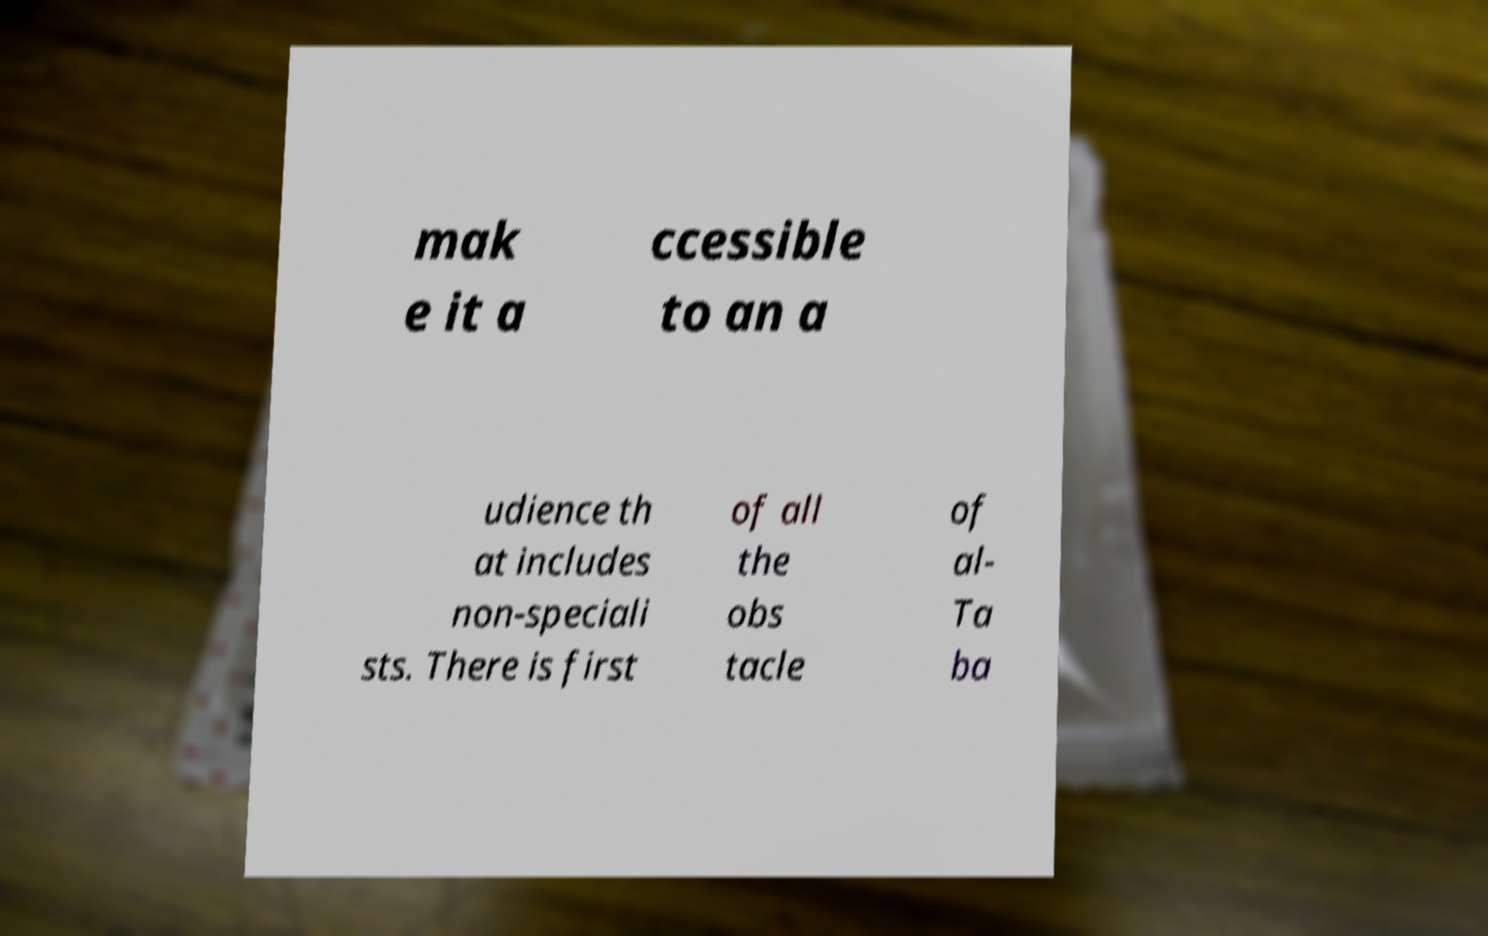There's text embedded in this image that I need extracted. Can you transcribe it verbatim? mak e it a ccessible to an a udience th at includes non-speciali sts. There is first of all the obs tacle of al- Ta ba 